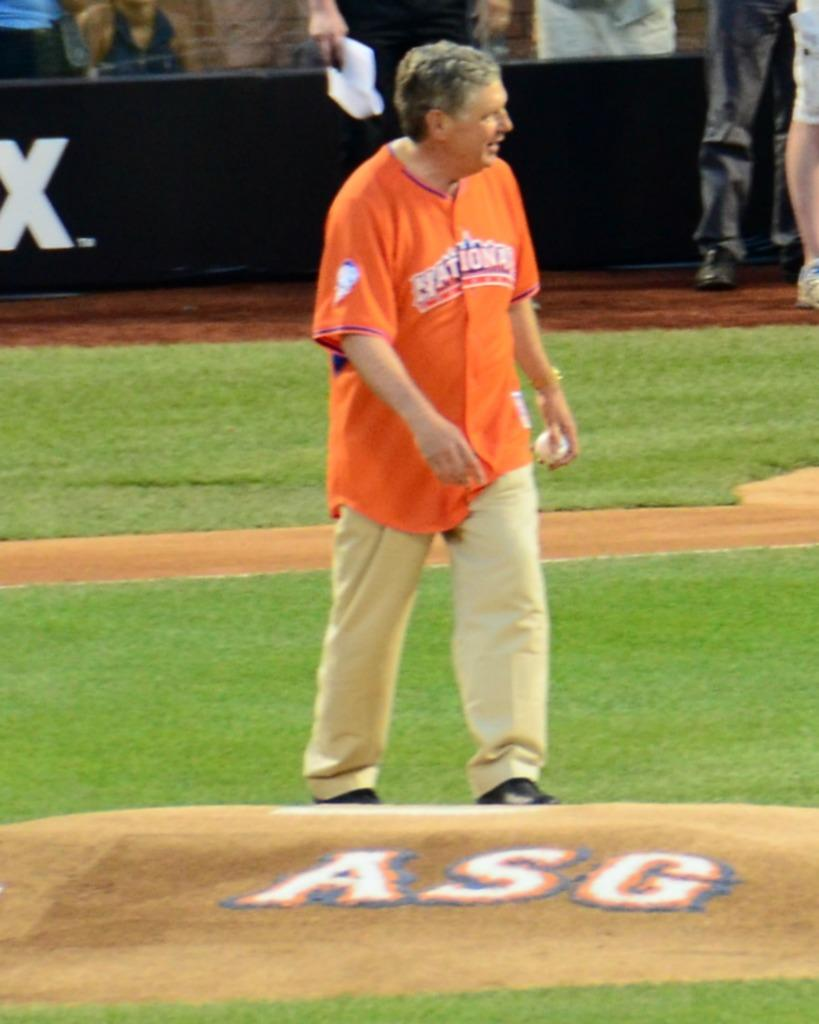<image>
Create a compact narrative representing the image presented. A man wearing a nationals jersey walks onto the pitcher's mound. 